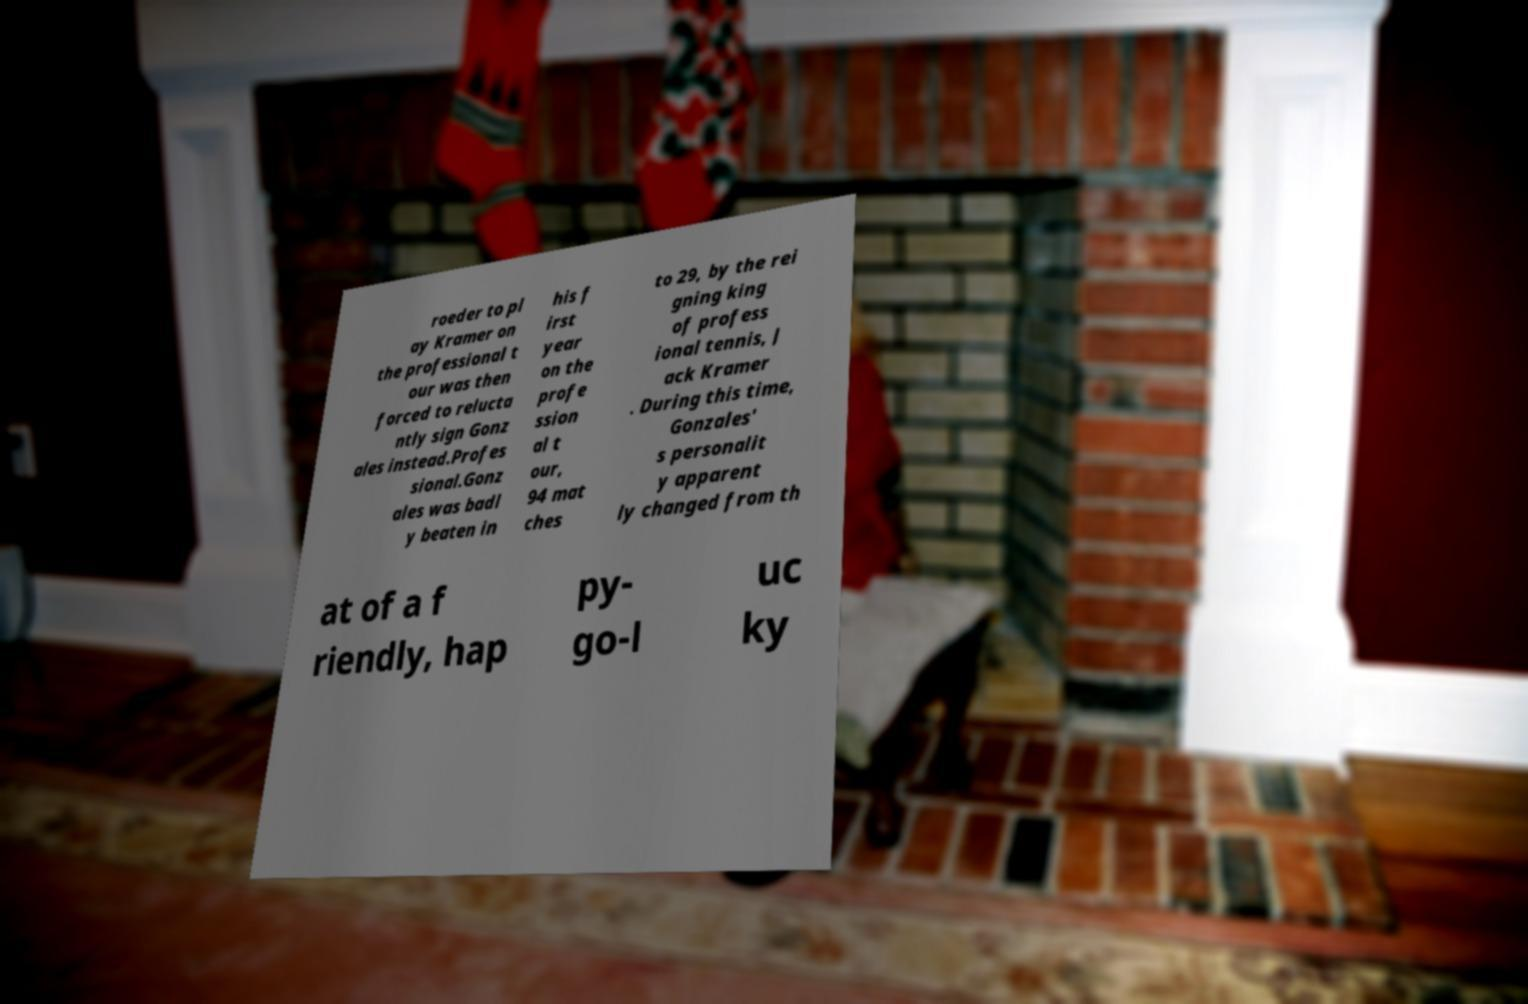There's text embedded in this image that I need extracted. Can you transcribe it verbatim? roeder to pl ay Kramer on the professional t our was then forced to relucta ntly sign Gonz ales instead.Profes sional.Gonz ales was badl y beaten in his f irst year on the profe ssion al t our, 94 mat ches to 29, by the rei gning king of profess ional tennis, J ack Kramer . During this time, Gonzales' s personalit y apparent ly changed from th at of a f riendly, hap py- go-l uc ky 